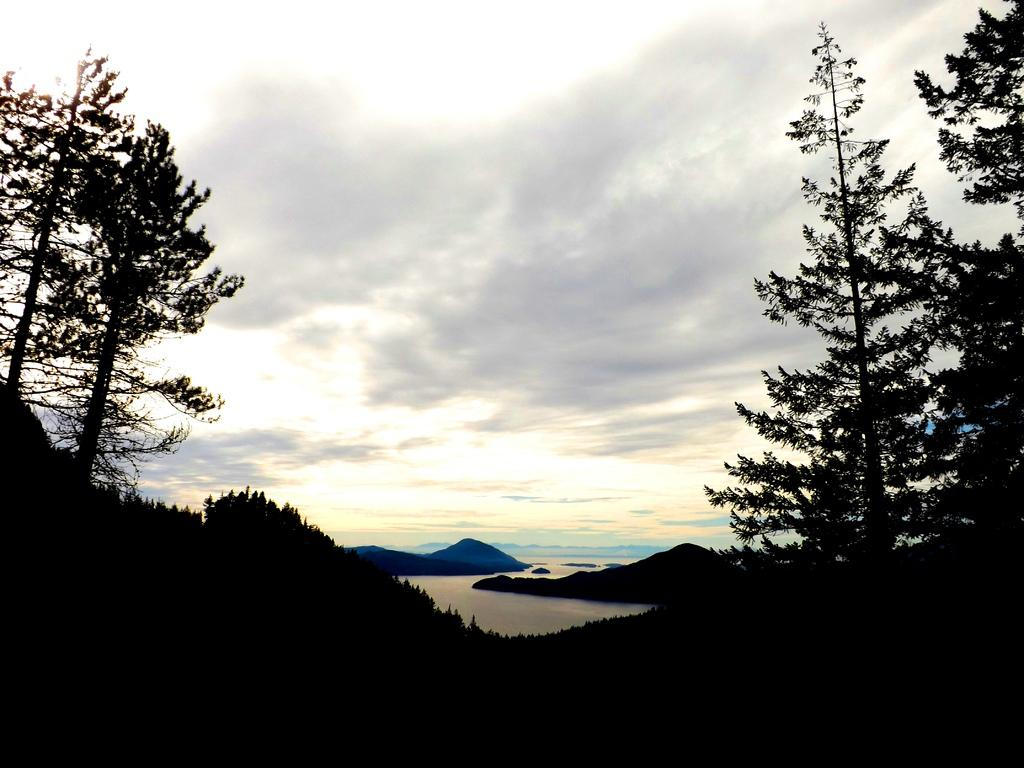What type of natural environment is depicted in the image? The image features many trees, mountains, and a river, indicating a natural landscape. Can you describe the river in the image? The river is located in the center of the image. What is visible at the top of the image? The sky is visible at the top of the image. What can be seen in the sky? Clouds are present in the sky. What type of teaching method is being demonstrated in the image? There is no teaching method or educational context present in the image; it features a natural landscape with trees, mountains, and a river. 